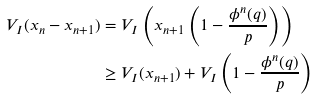Convert formula to latex. <formula><loc_0><loc_0><loc_500><loc_500>V _ { I } ( x _ { n } - x _ { n + 1 } ) & = V _ { I } \left ( x _ { n + 1 } \left ( 1 - \frac { \phi ^ { n } ( q ) } { p } \right ) \right ) \\ & \geq V _ { I } ( x _ { n + 1 } ) + V _ { I } \left ( 1 - \frac { \phi ^ { n } ( q ) } { p } \right )</formula> 